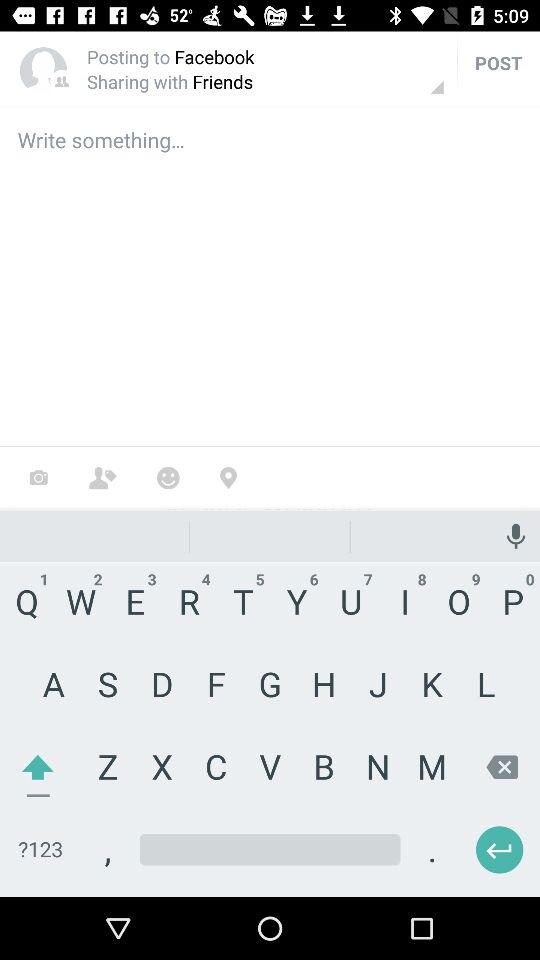Who developed "Sworkit"?
When the provided information is insufficient, respond with <no answer>. <no answer> 